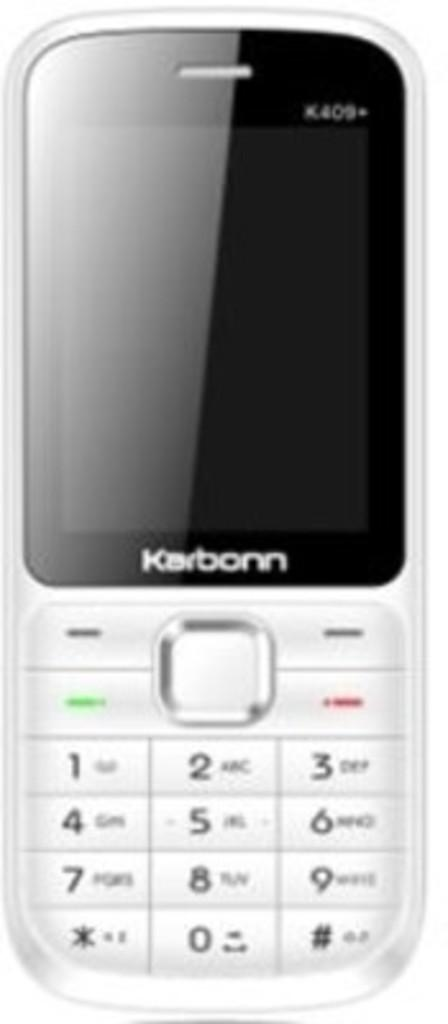<image>
Offer a succinct explanation of the picture presented. A silver cell phone says Karbonn on the front. 